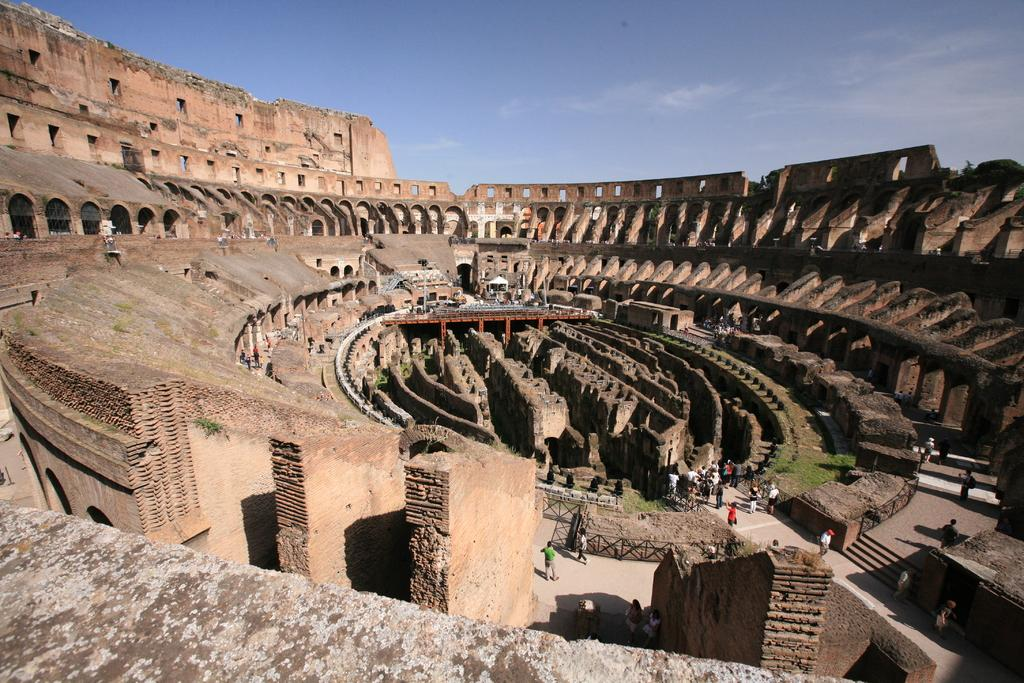What type of structures can be seen in the image? There are buildings in the image. Who or what else is present in the image? There are people in the image. What type of barrier can be seen in the image? There is a fence in the image. Are there any architectural features that allow for vertical movement in the image? Yes, there are stairs in the image. What part of the natural environment is visible in the image? The sky is visible in the image. What type of knife is being used by the people in the image? There is no knife present in the image. What is the tendency of the buildings to lean in the image? The buildings in the image do not appear to be leaning; they are standing upright. 